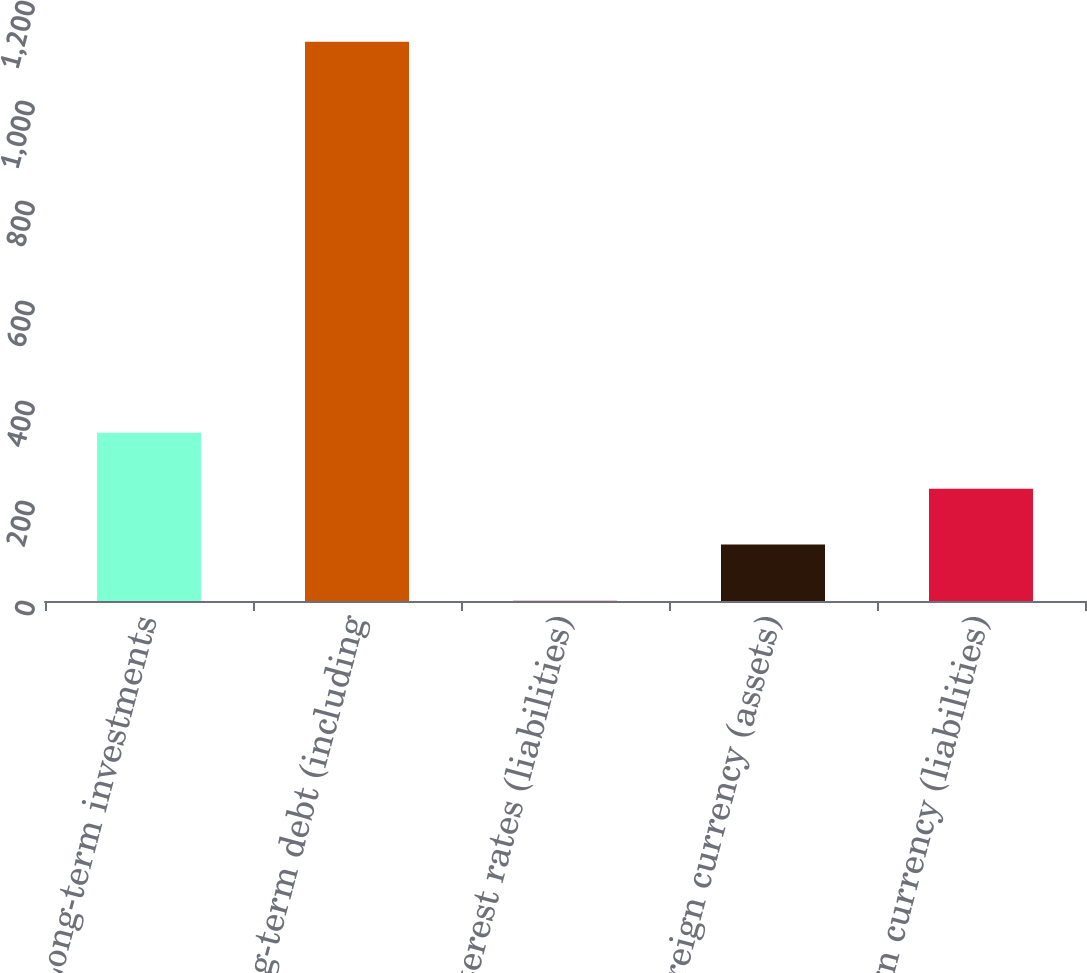Convert chart to OTSL. <chart><loc_0><loc_0><loc_500><loc_500><bar_chart><fcel>Long-term investments<fcel>Long-term debt (including<fcel>Interest rates (liabilities)<fcel>Foreign currency (assets)<fcel>Foreign currency (liabilities)<nl><fcel>336.33<fcel>1118.3<fcel>1.2<fcel>112.91<fcel>224.62<nl></chart> 